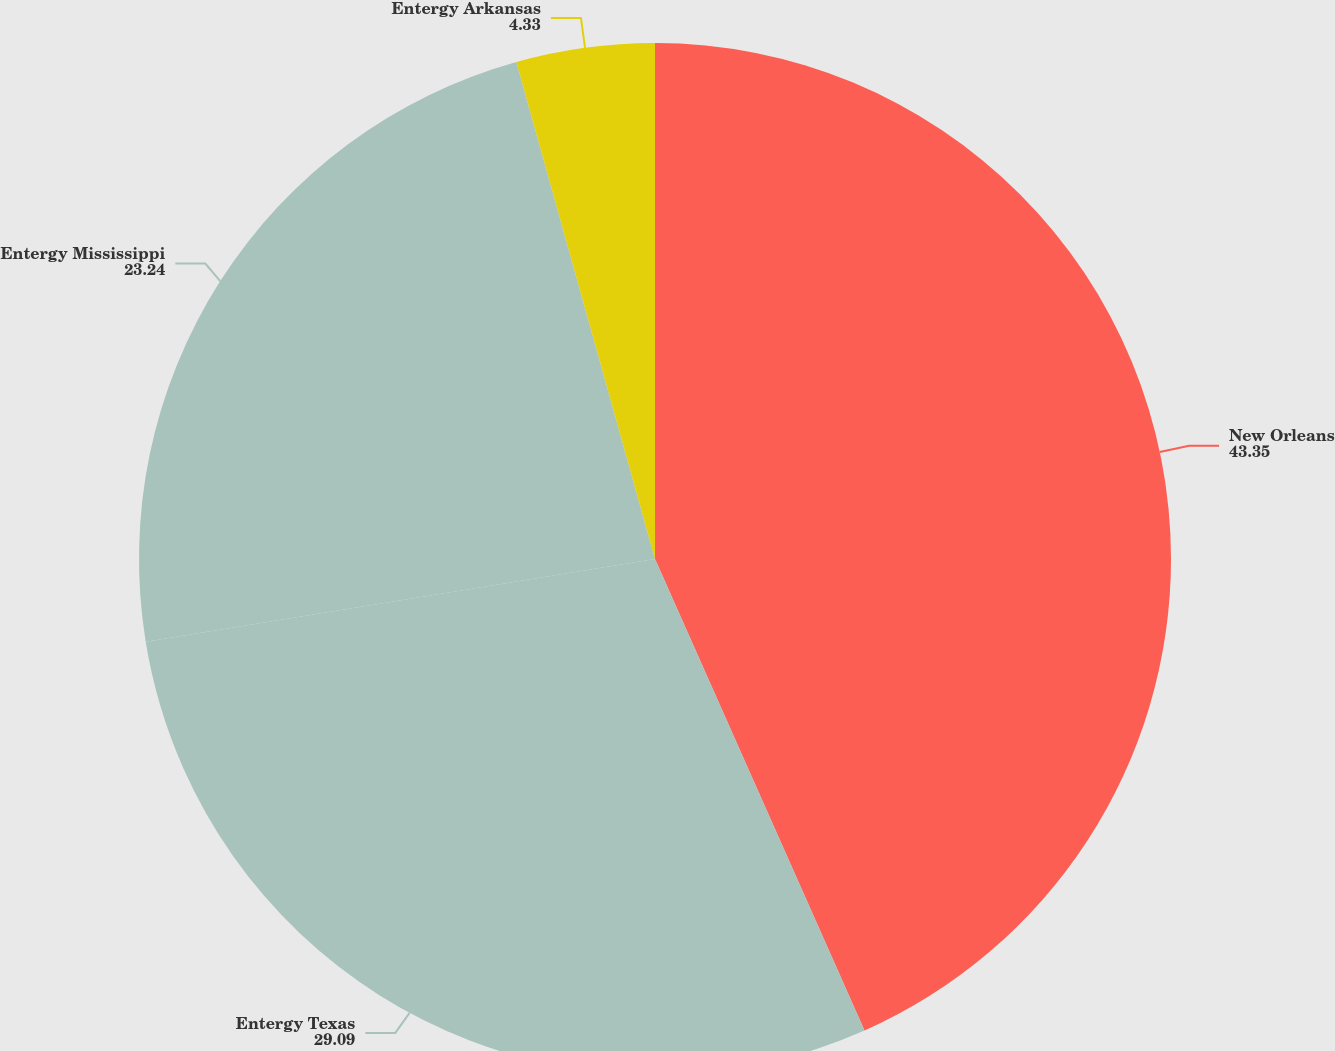Convert chart to OTSL. <chart><loc_0><loc_0><loc_500><loc_500><pie_chart><fcel>New Orleans<fcel>Entergy Texas<fcel>Entergy Mississippi<fcel>Entergy Arkansas<nl><fcel>43.35%<fcel>29.09%<fcel>23.24%<fcel>4.33%<nl></chart> 